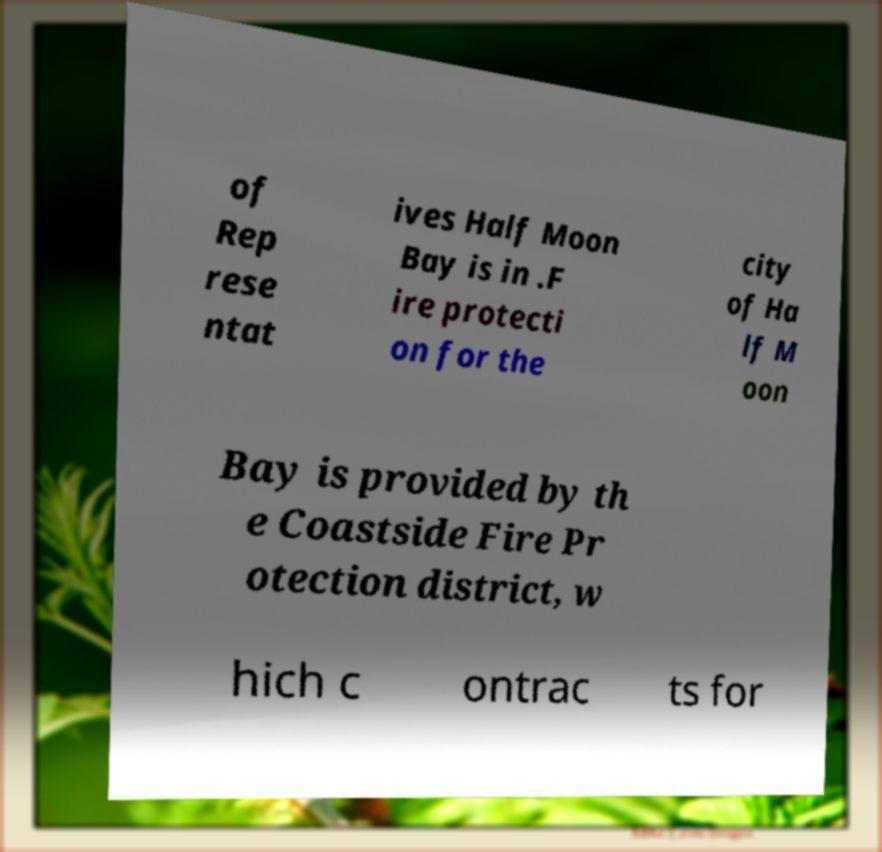Please identify and transcribe the text found in this image. of Rep rese ntat ives Half Moon Bay is in .F ire protecti on for the city of Ha lf M oon Bay is provided by th e Coastside Fire Pr otection district, w hich c ontrac ts for 